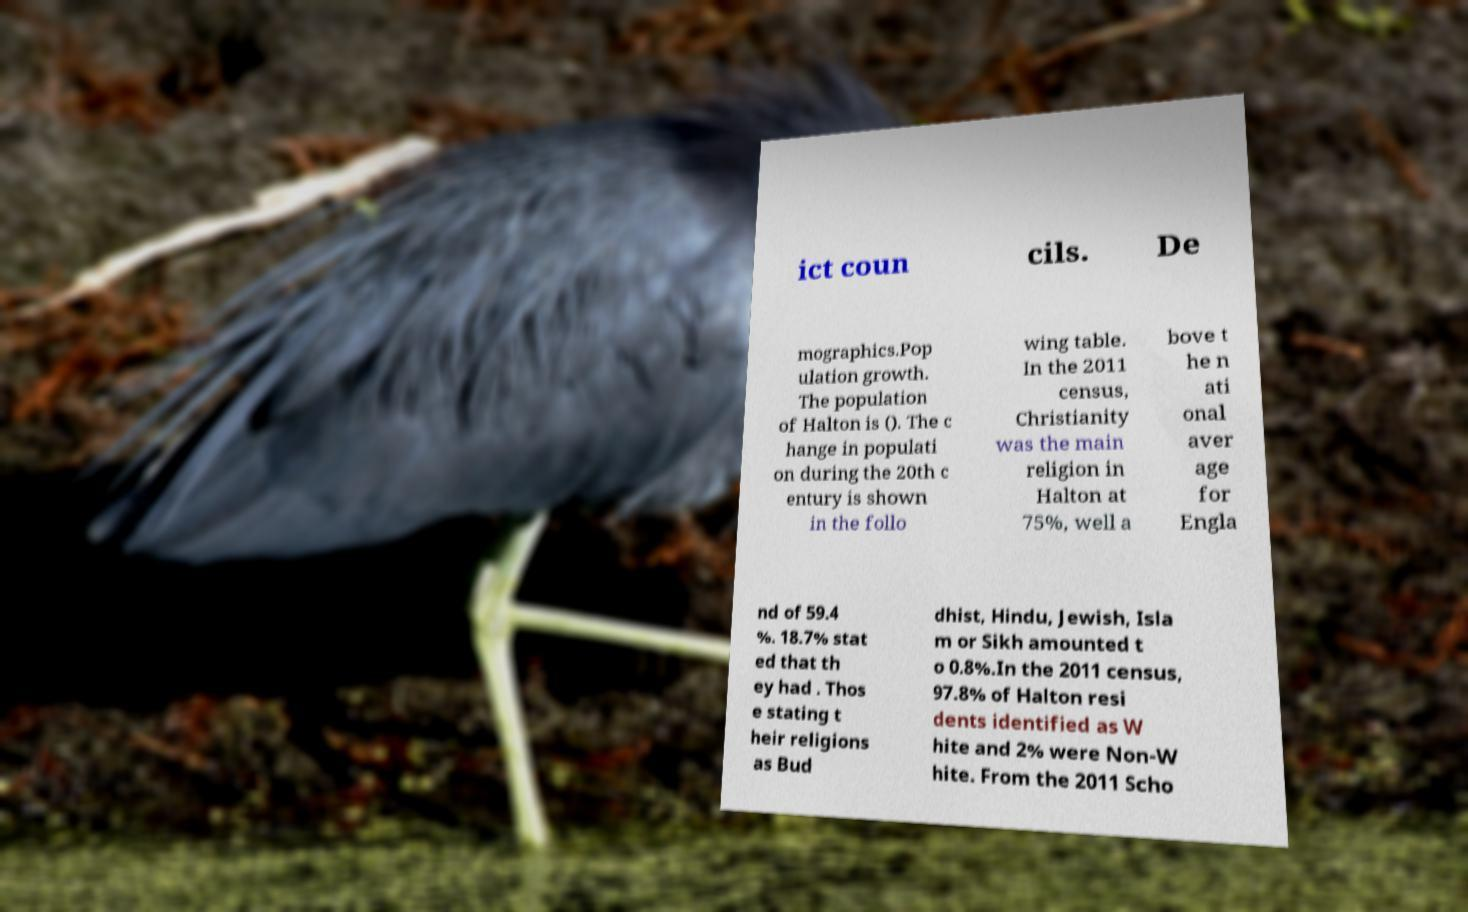I need the written content from this picture converted into text. Can you do that? ict coun cils. De mographics.Pop ulation growth. The population of Halton is (). The c hange in populati on during the 20th c entury is shown in the follo wing table. In the 2011 census, Christianity was the main religion in Halton at 75%, well a bove t he n ati onal aver age for Engla nd of 59.4 %. 18.7% stat ed that th ey had . Thos e stating t heir religions as Bud dhist, Hindu, Jewish, Isla m or Sikh amounted t o 0.8%.In the 2011 census, 97.8% of Halton resi dents identified as W hite and 2% were Non-W hite. From the 2011 Scho 